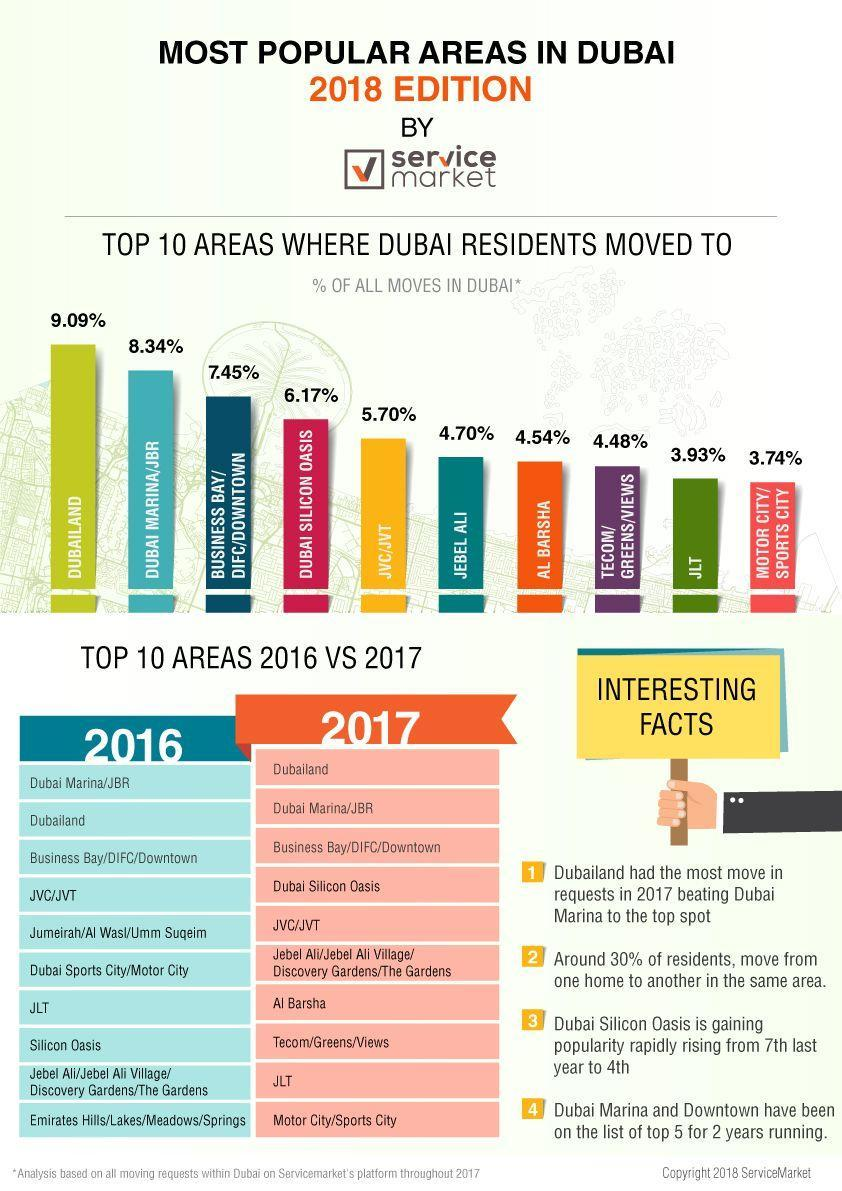Which are the two places that have taken that has replaced Jumeirah and Emirates Hills  in 2017 ranking?
Answer the question with a short phrase. Al Barsha, Tecom/Greens/Views Which residential area moved three places up in preference in 2017? Jebel Ali What percentage of Dubai residents preferred staying in Jebel Ali? 3.93% Which are was the fourth most preferred area of residence in Dubai? Dubai Silicon Oasis Which places in Dubai have less than four percentage of  move-ins? JLT, Motor City/ Sports City What was the percentage of residents who moved to JBR, 8.34%, 5.70%, or 3.93%? 8.34% Which residential area moved two places down in the preferred list in 2017? JLT 